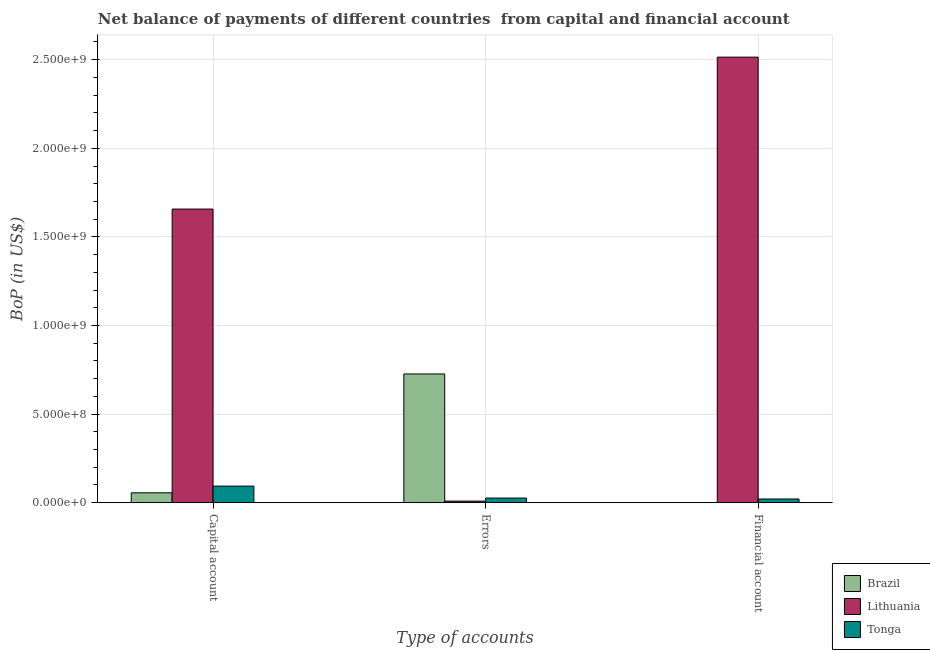How many different coloured bars are there?
Make the answer very short. 3. How many groups of bars are there?
Make the answer very short. 3. What is the label of the 1st group of bars from the left?
Keep it short and to the point. Capital account. What is the amount of net capital account in Tonga?
Offer a terse response. 9.33e+07. Across all countries, what is the maximum amount of financial account?
Give a very brief answer. 2.51e+09. In which country was the amount of net capital account maximum?
Your answer should be very brief. Lithuania. What is the total amount of financial account in the graph?
Offer a terse response. 2.54e+09. What is the difference between the amount of errors in Brazil and that in Tonga?
Provide a succinct answer. 7.00e+08. What is the difference between the amount of financial account in Brazil and the amount of errors in Tonga?
Make the answer very short. -2.58e+07. What is the average amount of errors per country?
Keep it short and to the point. 2.54e+08. What is the difference between the amount of financial account and amount of errors in Lithuania?
Keep it short and to the point. 2.51e+09. In how many countries, is the amount of errors greater than 1700000000 US$?
Offer a terse response. 0. What is the ratio of the amount of errors in Brazil to that in Tonga?
Your answer should be compact. 28.11. Is the difference between the amount of financial account in Tonga and Lithuania greater than the difference between the amount of net capital account in Tonga and Lithuania?
Keep it short and to the point. No. What is the difference between the highest and the second highest amount of errors?
Offer a very short reply. 7.00e+08. What is the difference between the highest and the lowest amount of net capital account?
Keep it short and to the point. 1.60e+09. Is the sum of the amount of net capital account in Lithuania and Tonga greater than the maximum amount of financial account across all countries?
Provide a short and direct response. No. Is it the case that in every country, the sum of the amount of net capital account and amount of errors is greater than the amount of financial account?
Your response must be concise. No. Are all the bars in the graph horizontal?
Offer a terse response. No. What is the difference between two consecutive major ticks on the Y-axis?
Offer a terse response. 5.00e+08. Are the values on the major ticks of Y-axis written in scientific E-notation?
Keep it short and to the point. Yes. Does the graph contain any zero values?
Make the answer very short. Yes. Does the graph contain grids?
Your answer should be compact. Yes. Where does the legend appear in the graph?
Provide a succinct answer. Bottom right. How many legend labels are there?
Ensure brevity in your answer.  3. What is the title of the graph?
Your response must be concise. Net balance of payments of different countries  from capital and financial account. What is the label or title of the X-axis?
Offer a terse response. Type of accounts. What is the label or title of the Y-axis?
Your answer should be very brief. BoP (in US$). What is the BoP (in US$) in Brazil in Capital account?
Your answer should be very brief. 5.56e+07. What is the BoP (in US$) in Lithuania in Capital account?
Your answer should be very brief. 1.66e+09. What is the BoP (in US$) of Tonga in Capital account?
Your response must be concise. 9.33e+07. What is the BoP (in US$) in Brazil in Errors?
Provide a short and direct response. 7.26e+08. What is the BoP (in US$) of Lithuania in Errors?
Give a very brief answer. 8.75e+06. What is the BoP (in US$) in Tonga in Errors?
Give a very brief answer. 2.58e+07. What is the BoP (in US$) in Brazil in Financial account?
Make the answer very short. 0. What is the BoP (in US$) of Lithuania in Financial account?
Provide a short and direct response. 2.51e+09. What is the BoP (in US$) in Tonga in Financial account?
Your answer should be compact. 2.06e+07. Across all Type of accounts, what is the maximum BoP (in US$) of Brazil?
Give a very brief answer. 7.26e+08. Across all Type of accounts, what is the maximum BoP (in US$) in Lithuania?
Your answer should be compact. 2.51e+09. Across all Type of accounts, what is the maximum BoP (in US$) in Tonga?
Give a very brief answer. 9.33e+07. Across all Type of accounts, what is the minimum BoP (in US$) of Brazil?
Keep it short and to the point. 0. Across all Type of accounts, what is the minimum BoP (in US$) of Lithuania?
Provide a short and direct response. 8.75e+06. Across all Type of accounts, what is the minimum BoP (in US$) of Tonga?
Offer a terse response. 2.06e+07. What is the total BoP (in US$) in Brazil in the graph?
Make the answer very short. 7.82e+08. What is the total BoP (in US$) of Lithuania in the graph?
Give a very brief answer. 4.18e+09. What is the total BoP (in US$) of Tonga in the graph?
Provide a short and direct response. 1.40e+08. What is the difference between the BoP (in US$) of Brazil in Capital account and that in Errors?
Give a very brief answer. -6.71e+08. What is the difference between the BoP (in US$) of Lithuania in Capital account and that in Errors?
Your answer should be very brief. 1.65e+09. What is the difference between the BoP (in US$) of Tonga in Capital account and that in Errors?
Provide a succinct answer. 6.74e+07. What is the difference between the BoP (in US$) in Lithuania in Capital account and that in Financial account?
Your answer should be very brief. -8.57e+08. What is the difference between the BoP (in US$) in Tonga in Capital account and that in Financial account?
Make the answer very short. 7.27e+07. What is the difference between the BoP (in US$) in Lithuania in Errors and that in Financial account?
Your response must be concise. -2.51e+09. What is the difference between the BoP (in US$) in Tonga in Errors and that in Financial account?
Give a very brief answer. 5.23e+06. What is the difference between the BoP (in US$) of Brazil in Capital account and the BoP (in US$) of Lithuania in Errors?
Your answer should be very brief. 4.68e+07. What is the difference between the BoP (in US$) in Brazil in Capital account and the BoP (in US$) in Tonga in Errors?
Offer a very short reply. 2.97e+07. What is the difference between the BoP (in US$) in Lithuania in Capital account and the BoP (in US$) in Tonga in Errors?
Provide a succinct answer. 1.63e+09. What is the difference between the BoP (in US$) in Brazil in Capital account and the BoP (in US$) in Lithuania in Financial account?
Your answer should be compact. -2.46e+09. What is the difference between the BoP (in US$) of Brazil in Capital account and the BoP (in US$) of Tonga in Financial account?
Your answer should be very brief. 3.49e+07. What is the difference between the BoP (in US$) of Lithuania in Capital account and the BoP (in US$) of Tonga in Financial account?
Give a very brief answer. 1.64e+09. What is the difference between the BoP (in US$) in Brazil in Errors and the BoP (in US$) in Lithuania in Financial account?
Give a very brief answer. -1.79e+09. What is the difference between the BoP (in US$) in Brazil in Errors and the BoP (in US$) in Tonga in Financial account?
Offer a terse response. 7.06e+08. What is the difference between the BoP (in US$) in Lithuania in Errors and the BoP (in US$) in Tonga in Financial account?
Offer a terse response. -1.19e+07. What is the average BoP (in US$) in Brazil per Type of accounts?
Make the answer very short. 2.61e+08. What is the average BoP (in US$) of Lithuania per Type of accounts?
Provide a succinct answer. 1.39e+09. What is the average BoP (in US$) in Tonga per Type of accounts?
Your answer should be compact. 4.66e+07. What is the difference between the BoP (in US$) of Brazil and BoP (in US$) of Lithuania in Capital account?
Make the answer very short. -1.60e+09. What is the difference between the BoP (in US$) in Brazil and BoP (in US$) in Tonga in Capital account?
Your answer should be very brief. -3.77e+07. What is the difference between the BoP (in US$) in Lithuania and BoP (in US$) in Tonga in Capital account?
Your answer should be compact. 1.56e+09. What is the difference between the BoP (in US$) in Brazil and BoP (in US$) in Lithuania in Errors?
Ensure brevity in your answer.  7.18e+08. What is the difference between the BoP (in US$) of Brazil and BoP (in US$) of Tonga in Errors?
Provide a short and direct response. 7.00e+08. What is the difference between the BoP (in US$) of Lithuania and BoP (in US$) of Tonga in Errors?
Offer a terse response. -1.71e+07. What is the difference between the BoP (in US$) in Lithuania and BoP (in US$) in Tonga in Financial account?
Give a very brief answer. 2.49e+09. What is the ratio of the BoP (in US$) in Brazil in Capital account to that in Errors?
Your response must be concise. 0.08. What is the ratio of the BoP (in US$) of Lithuania in Capital account to that in Errors?
Offer a very short reply. 189.47. What is the ratio of the BoP (in US$) of Tonga in Capital account to that in Errors?
Keep it short and to the point. 3.61. What is the ratio of the BoP (in US$) of Lithuania in Capital account to that in Financial account?
Provide a succinct answer. 0.66. What is the ratio of the BoP (in US$) in Tonga in Capital account to that in Financial account?
Your answer should be compact. 4.53. What is the ratio of the BoP (in US$) of Lithuania in Errors to that in Financial account?
Ensure brevity in your answer.  0. What is the ratio of the BoP (in US$) of Tonga in Errors to that in Financial account?
Give a very brief answer. 1.25. What is the difference between the highest and the second highest BoP (in US$) in Lithuania?
Make the answer very short. 8.57e+08. What is the difference between the highest and the second highest BoP (in US$) of Tonga?
Offer a terse response. 6.74e+07. What is the difference between the highest and the lowest BoP (in US$) of Brazil?
Your response must be concise. 7.26e+08. What is the difference between the highest and the lowest BoP (in US$) of Lithuania?
Your answer should be very brief. 2.51e+09. What is the difference between the highest and the lowest BoP (in US$) in Tonga?
Ensure brevity in your answer.  7.27e+07. 